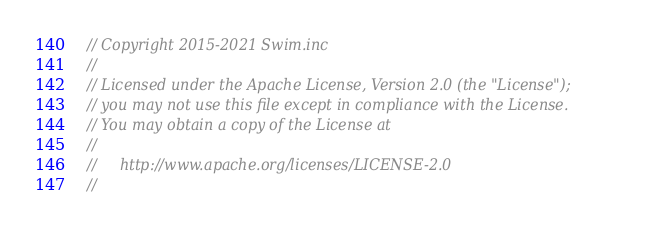Convert code to text. <code><loc_0><loc_0><loc_500><loc_500><_TypeScript_>// Copyright 2015-2021 Swim.inc
//
// Licensed under the Apache License, Version 2.0 (the "License");
// you may not use this file except in compliance with the License.
// You may obtain a copy of the License at
//
//     http://www.apache.org/licenses/LICENSE-2.0
//</code> 